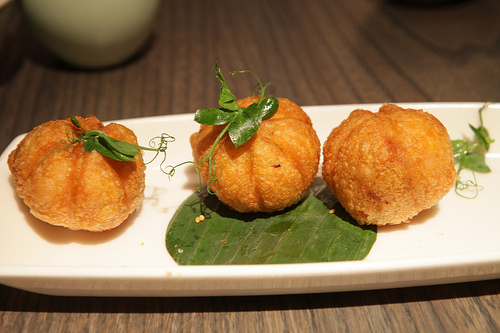<image>
Can you confirm if the plate is next to the food? No. The plate is not positioned next to the food. They are located in different areas of the scene. 